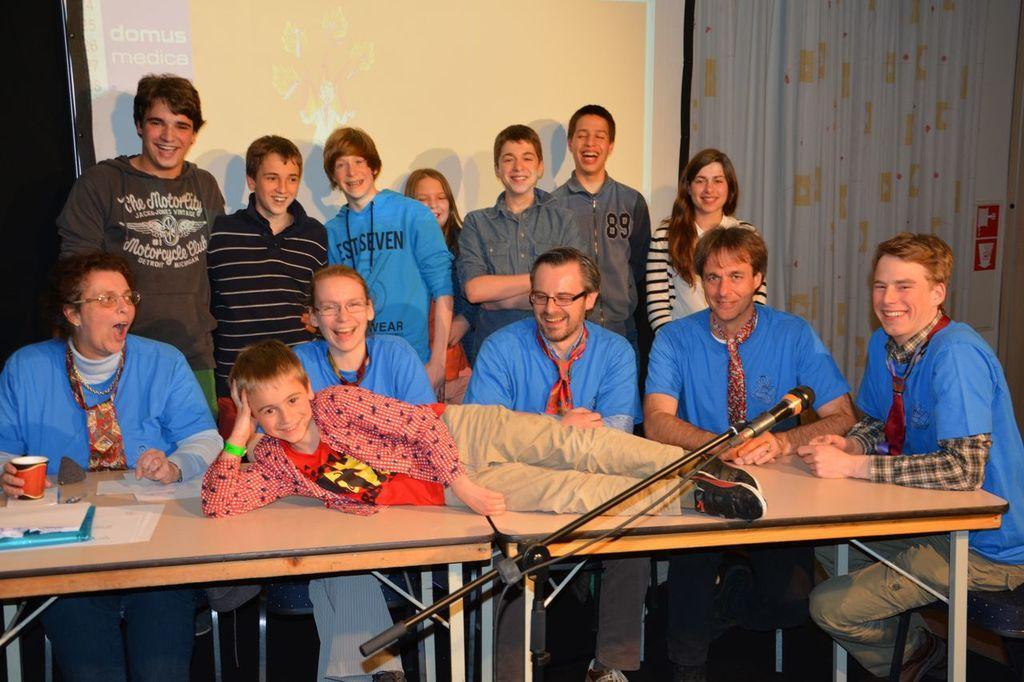In one or two sentences, can you explain what this image depicts? A boy is lying on a table. There are some people around the table. some boys and girls are standing behind them. 